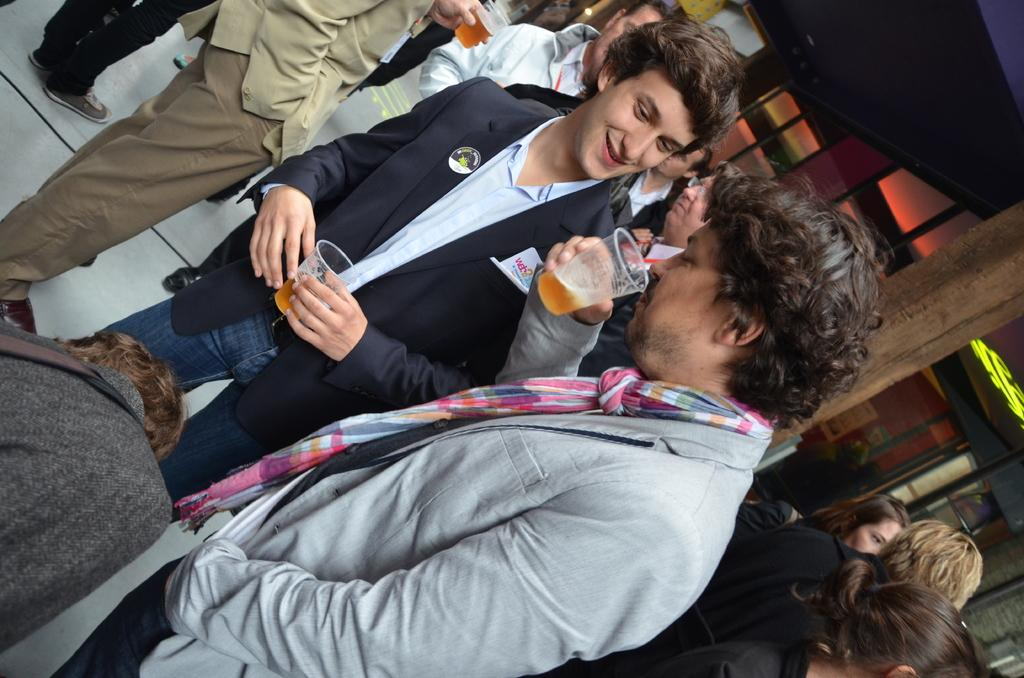How is the image oriented? The image is tilted. What can be seen in the image besides the tilted orientation? There is a group of people in the image. Where are the people located? The people are inside a hall. What are the people doing in the image? The people are drinking. What type of prose can be heard being recited by the people in the image? There is no indication in the image that the people are reciting any prose, so it cannot be determined from the picture. 